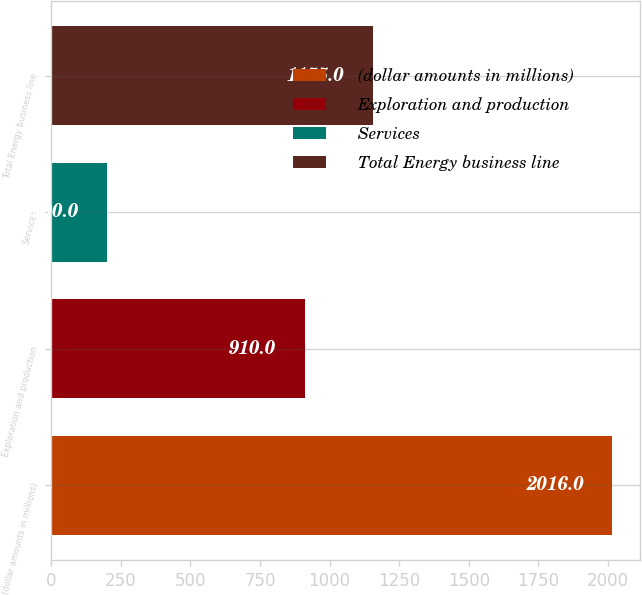Convert chart to OTSL. <chart><loc_0><loc_0><loc_500><loc_500><bar_chart><fcel>(dollar amounts in millions)<fcel>Exploration and production<fcel>Services<fcel>Total Energy business line<nl><fcel>2016<fcel>910<fcel>200<fcel>1155<nl></chart> 